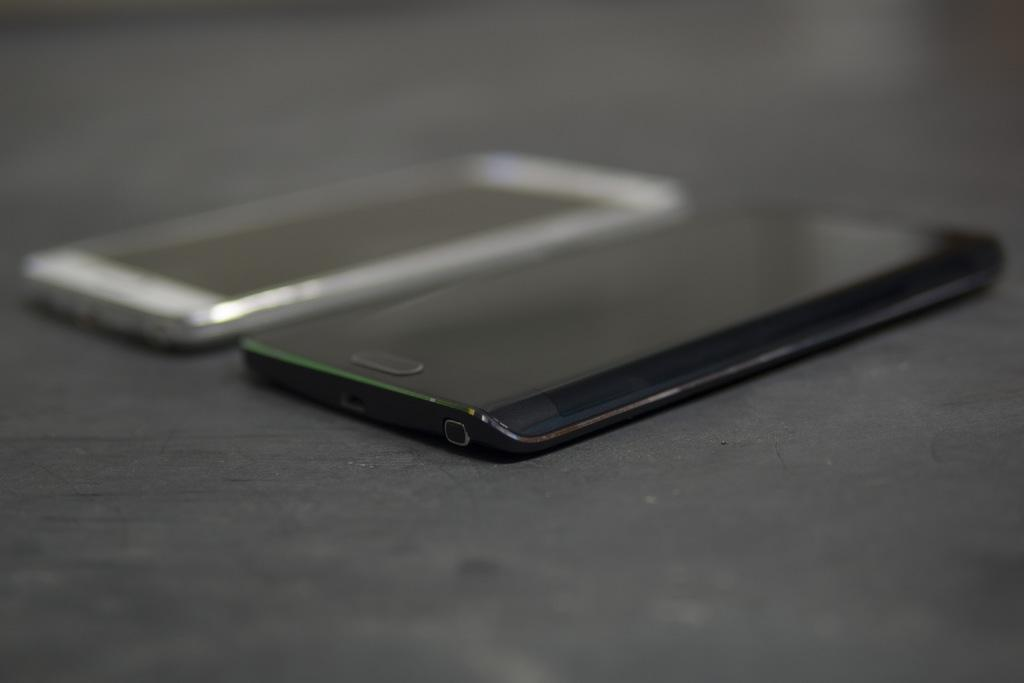How many mobile phones are present in the image? There are two mobile phones in the image. What are the colors of the mobile phones? One mobile phone is white in color, and the other mobile phone is black in color. Can you describe any specific feature of the mobile phones? Yes, there is a home button visible in the image. Reasoning: Let's think step by step by step in order to produce the conversation. We start by identifying the main subject in the image, which is the mobile phones. Then, we expand the conversation to include the colors of the mobile phones and a specific feature, the home button. Each question is designed to elicit a specific detail about the image that is known from the provided facts. Absurd Question/Answer: What type of smell can be detected from the mobile phones in the image? There is no smell associated with the mobile phones in the image, as they are electronic devices. 